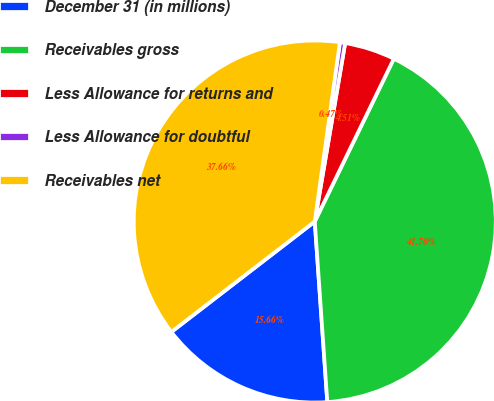<chart> <loc_0><loc_0><loc_500><loc_500><pie_chart><fcel>December 31 (in millions)<fcel>Receivables gross<fcel>Less Allowance for returns and<fcel>Less Allowance for doubtful<fcel>Receivables net<nl><fcel>15.66%<fcel>41.7%<fcel>4.51%<fcel>0.47%<fcel>37.66%<nl></chart> 